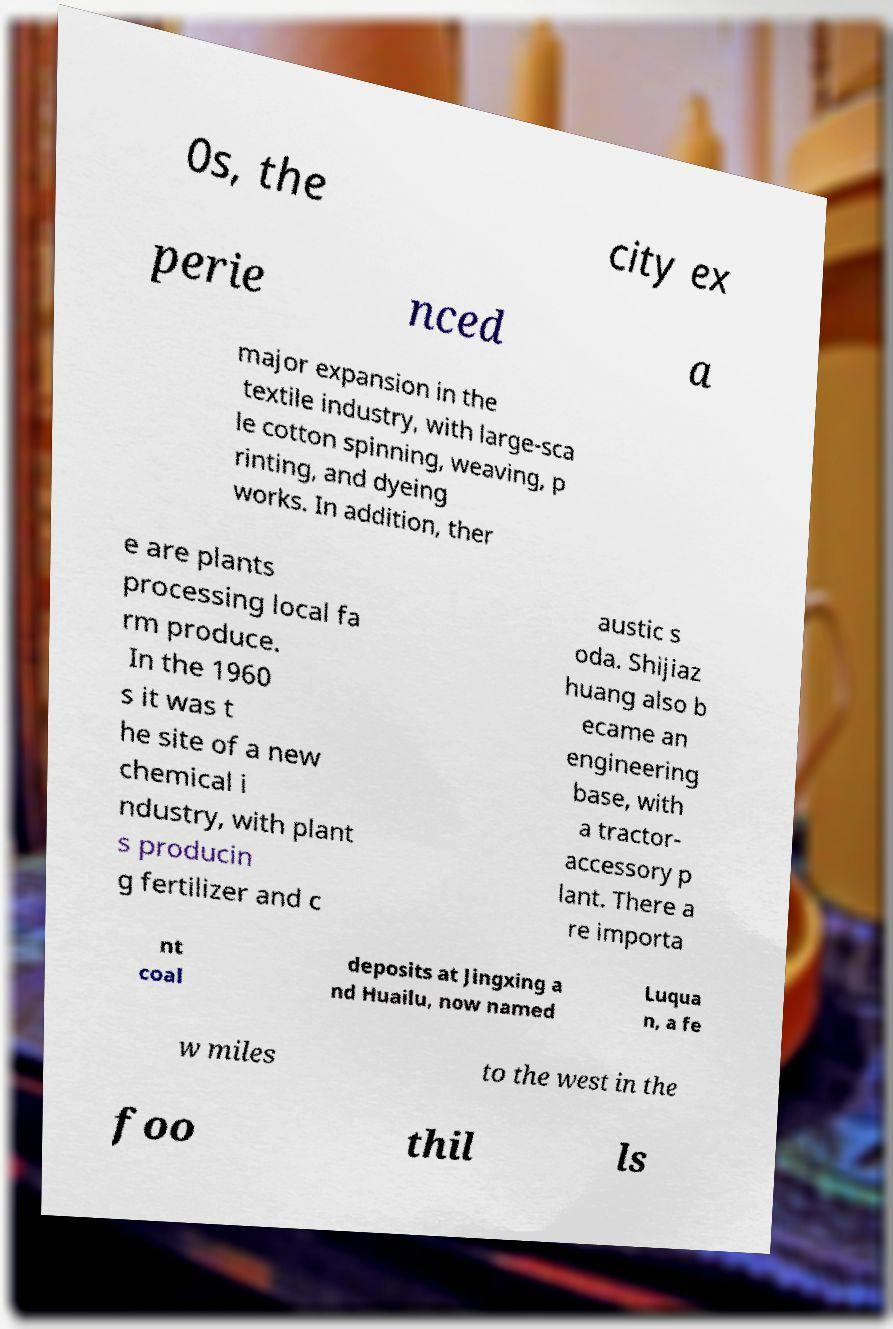For documentation purposes, I need the text within this image transcribed. Could you provide that? 0s, the city ex perie nced a major expansion in the textile industry, with large-sca le cotton spinning, weaving, p rinting, and dyeing works. In addition, ther e are plants processing local fa rm produce. In the 1960 s it was t he site of a new chemical i ndustry, with plant s producin g fertilizer and c austic s oda. Shijiaz huang also b ecame an engineering base, with a tractor- accessory p lant. There a re importa nt coal deposits at Jingxing a nd Huailu, now named Luqua n, a fe w miles to the west in the foo thil ls 